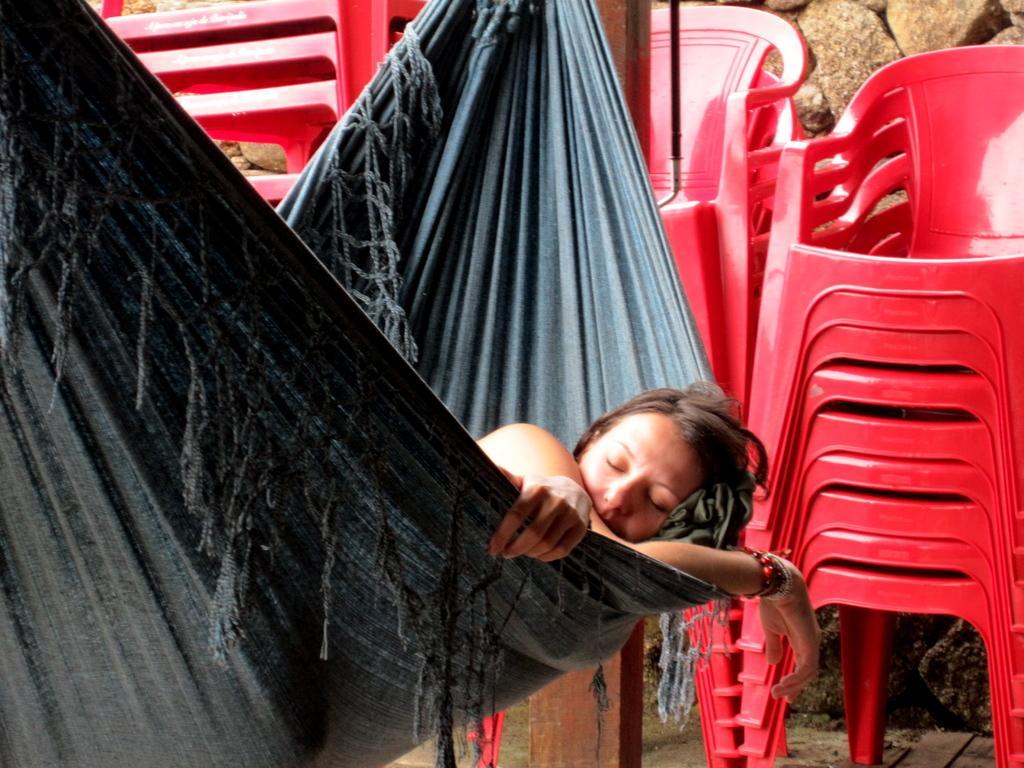Can you describe this image briefly? In the front of the image I can see a woman is sleeping in a swing. In the background of the image there are rocks, chairs and objects. 